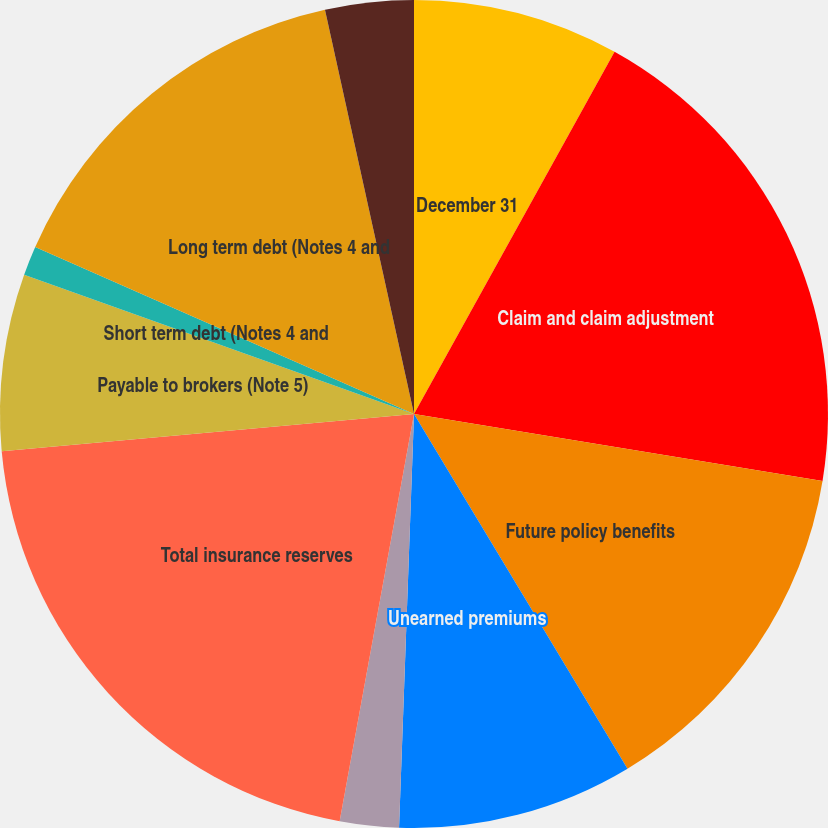Convert chart to OTSL. <chart><loc_0><loc_0><loc_500><loc_500><pie_chart><fcel>December 31<fcel>Claim and claim adjustment<fcel>Future policy benefits<fcel>Unearned premiums<fcel>Policyholders' funds<fcel>Total insurance reserves<fcel>Payable to brokers (Note 5)<fcel>Short term debt (Notes 4 and<fcel>Long term debt (Notes 4 and<fcel>Reinsurance balances payable<nl><fcel>8.05%<fcel>19.54%<fcel>13.79%<fcel>9.2%<fcel>2.3%<fcel>20.69%<fcel>6.9%<fcel>1.15%<fcel>14.94%<fcel>3.45%<nl></chart> 